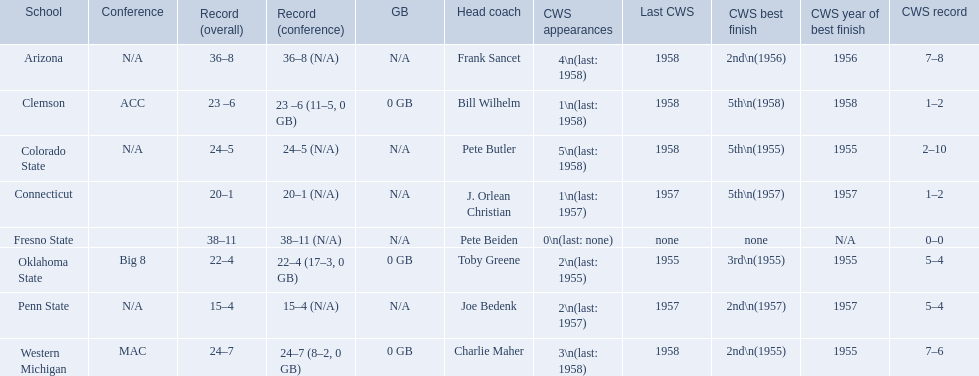What are all of the schools? Arizona, Clemson, Colorado State, Connecticut, Fresno State, Oklahoma State, Penn State, Western Michigan. Which team had fewer than 20 wins? Penn State. 